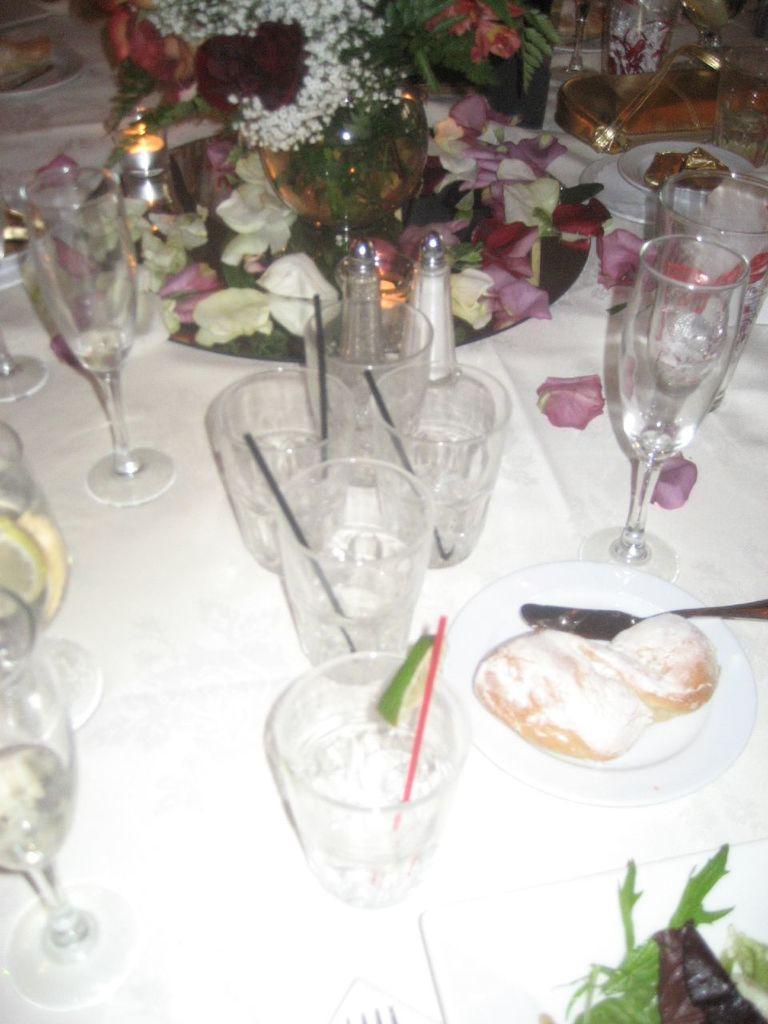In one or two sentences, can you explain what this image depicts? There is table in the image. On the table there are glasses with straws in it, food in plates, knives, wine glasses, candles and a flower vase. At the above right corner there is golden handbag. There are flowers on the table. In the vase there is water and flowers.  